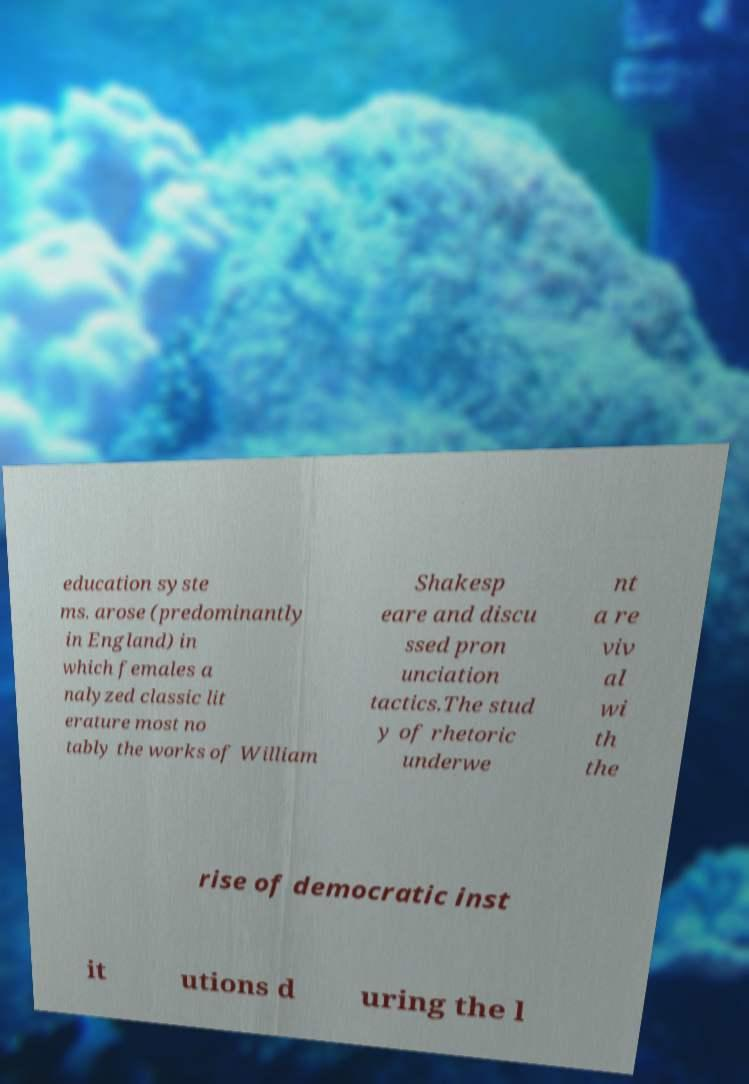For documentation purposes, I need the text within this image transcribed. Could you provide that? education syste ms. arose (predominantly in England) in which females a nalyzed classic lit erature most no tably the works of William Shakesp eare and discu ssed pron unciation tactics.The stud y of rhetoric underwe nt a re viv al wi th the rise of democratic inst it utions d uring the l 